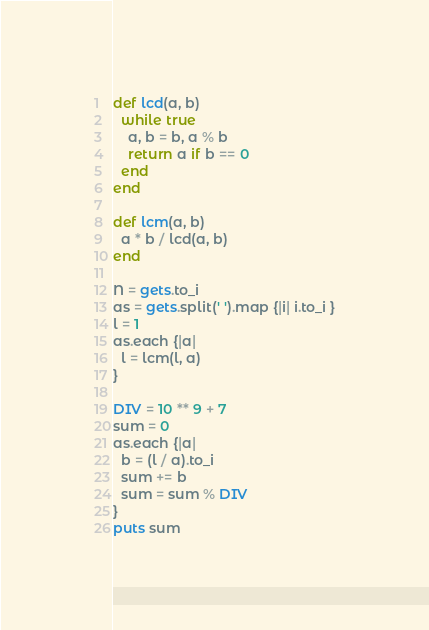Convert code to text. <code><loc_0><loc_0><loc_500><loc_500><_Ruby_>def lcd(a, b)
  while true
    a, b = b, a % b
    return a if b == 0
  end
end

def lcm(a, b)
  a * b / lcd(a, b)
end

N = gets.to_i
as = gets.split(' ').map {|i| i.to_i }
l = 1
as.each {|a|
  l = lcm(l, a)
}

DIV = 10 ** 9 + 7
sum = 0
as.each {|a|
  b = (l / a).to_i
  sum += b
  sum = sum % DIV
}
puts sum

</code> 